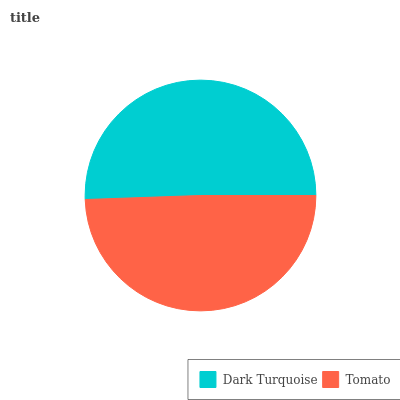Is Tomato the minimum?
Answer yes or no. Yes. Is Dark Turquoise the maximum?
Answer yes or no. Yes. Is Tomato the maximum?
Answer yes or no. No. Is Dark Turquoise greater than Tomato?
Answer yes or no. Yes. Is Tomato less than Dark Turquoise?
Answer yes or no. Yes. Is Tomato greater than Dark Turquoise?
Answer yes or no. No. Is Dark Turquoise less than Tomato?
Answer yes or no. No. Is Dark Turquoise the high median?
Answer yes or no. Yes. Is Tomato the low median?
Answer yes or no. Yes. Is Tomato the high median?
Answer yes or no. No. Is Dark Turquoise the low median?
Answer yes or no. No. 